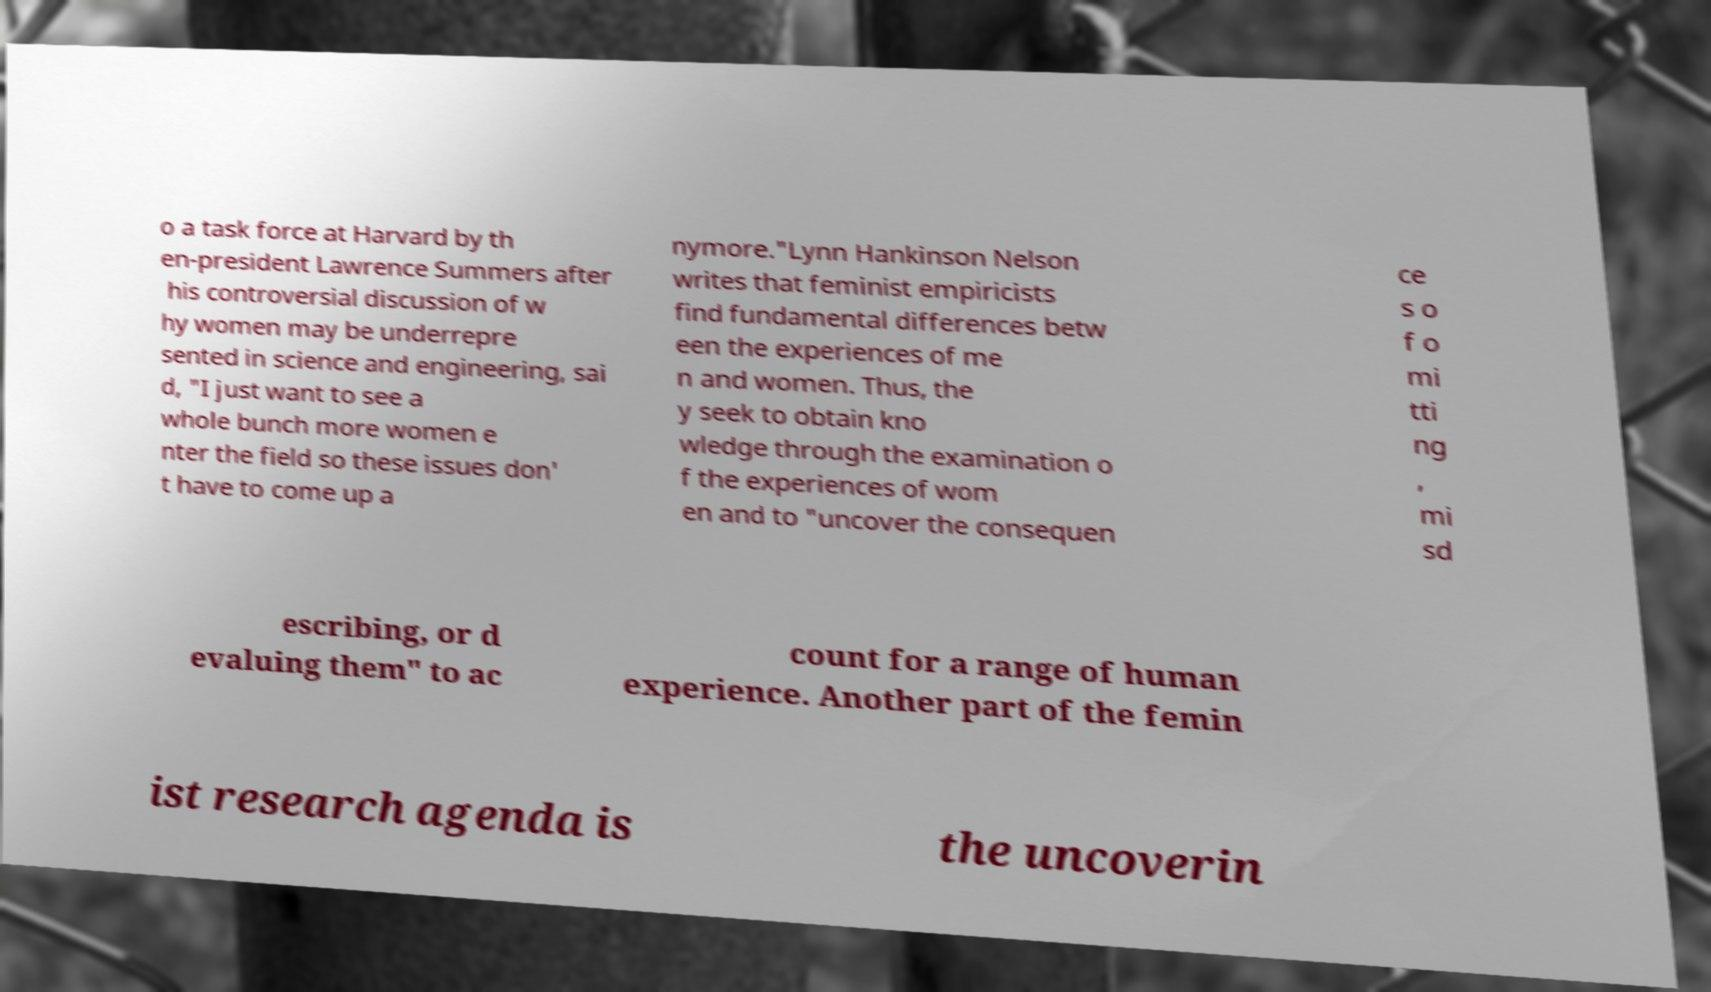Please read and relay the text visible in this image. What does it say? o a task force at Harvard by th en-president Lawrence Summers after his controversial discussion of w hy women may be underrepre sented in science and engineering, sai d, "I just want to see a whole bunch more women e nter the field so these issues don' t have to come up a nymore."Lynn Hankinson Nelson writes that feminist empiricists find fundamental differences betw een the experiences of me n and women. Thus, the y seek to obtain kno wledge through the examination o f the experiences of wom en and to "uncover the consequen ce s o f o mi tti ng , mi sd escribing, or d evaluing them" to ac count for a range of human experience. Another part of the femin ist research agenda is the uncoverin 